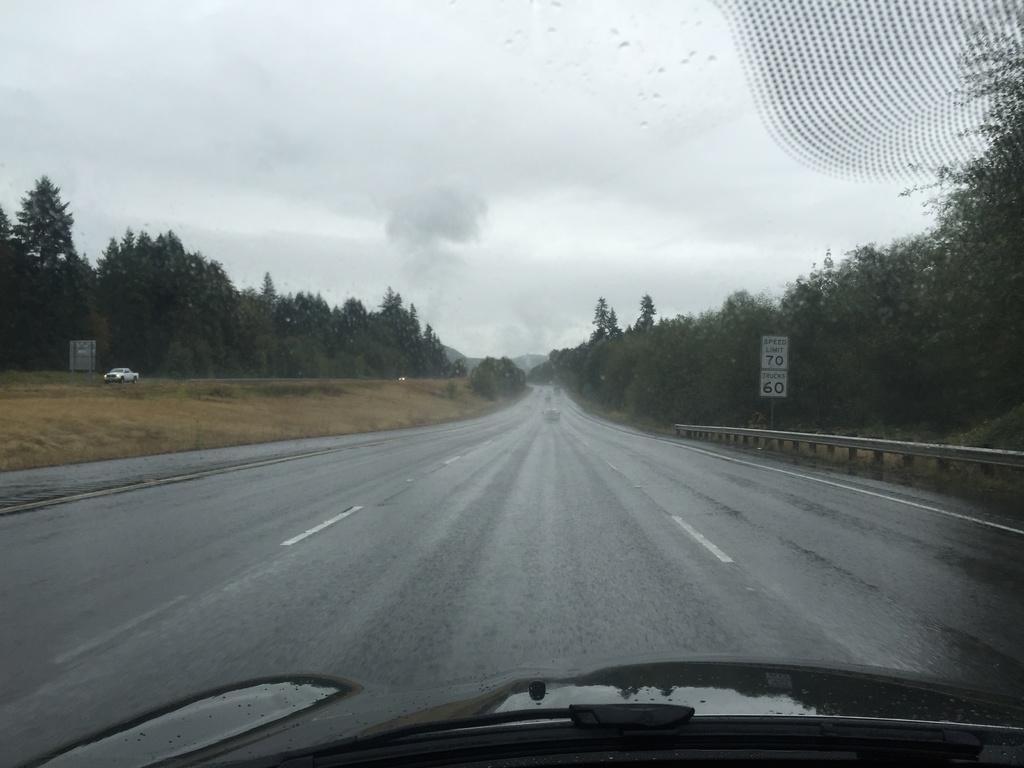Describe this image in one or two sentences. In the center of the image there are cars on the road. There are boards with some text on it. In the background of the image there is grass on the surface. There are trees, mountains. On the right side of the image there is some design on the windshield. At the bottom of the image there are wipers and a bonnet of a car. At the top of the image there is sky. 